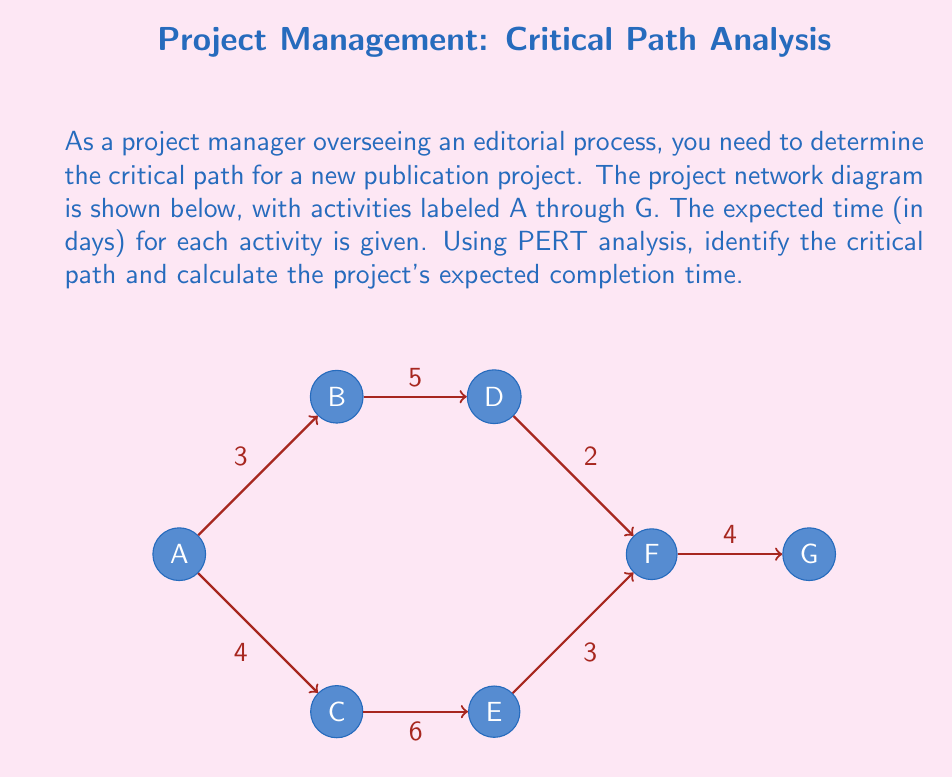Teach me how to tackle this problem. To determine the critical path using PERT analysis, we need to calculate the earliest start time (EST) and latest finish time (LFT) for each activity. The critical path is the sequence of activities where any delay will result in a delay of the entire project.

Step 1: Forward Pass (Calculate EST)
- Start with activity A: EST(A) = 0
- B: EST(B) = EST(A) + Duration(A) = 0 + 3 = 3
- C: EST(C) = EST(A) + Duration(A) = 0 + 4 = 4
- D: EST(D) = EST(B) + Duration(B) = 3 + 5 = 8
- E: EST(E) = EST(C) + Duration(C) = 4 + 6 = 10
- F: EST(F) = max(EST(D) + Duration(D), EST(E) + Duration(E)) = max(8 + 2, 10 + 3) = 13
- G: EST(G) = EST(F) + Duration(F) = 13 + 4 = 17

Step 2: Backward Pass (Calculate LFT)
- Start with activity G: LFT(G) = 17
- F: LFT(F) = LFT(G) - Duration(G) = 17 - 4 = 13
- D and E: LFT(D) = LFT(E) = LFT(F) - Duration(F) = 13 - 3 = 10
- B: LFT(B) = LFT(D) - Duration(D) = 10 - 5 = 5
- C: LFT(C) = LFT(E) - Duration(E) = 10 - 6 = 4
- A: LFT(A) = min(LFT(B) - Duration(B), LFT(C) - Duration(C)) = min(5 - 3, 4 - 4) = 0

Step 3: Calculate Float
Float = LFT - EST - Duration
- A: 0 - 0 - 3 = -3 (on critical path)
- B: 5 - 3 - 5 = -3 (on critical path)
- C: 4 - 4 - 6 = -6 (on critical path)
- D: 10 - 8 - 2 = 0
- E: 10 - 10 - 3 = -3 (on critical path)
- F: 13 - 13 - 4 = -4 (on critical path)
- G: 17 - 17 - 4 = -4 (on critical path)

The critical path is the sequence of activities with zero or negative float: A → C → E → F → G

The expected completion time is the EST of the last activity, which is 17 days.
Answer: Critical path: A → C → E → F → G; Expected completion time: 17 days 